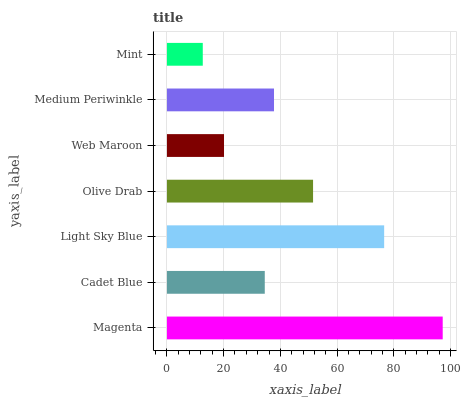Is Mint the minimum?
Answer yes or no. Yes. Is Magenta the maximum?
Answer yes or no. Yes. Is Cadet Blue the minimum?
Answer yes or no. No. Is Cadet Blue the maximum?
Answer yes or no. No. Is Magenta greater than Cadet Blue?
Answer yes or no. Yes. Is Cadet Blue less than Magenta?
Answer yes or no. Yes. Is Cadet Blue greater than Magenta?
Answer yes or no. No. Is Magenta less than Cadet Blue?
Answer yes or no. No. Is Medium Periwinkle the high median?
Answer yes or no. Yes. Is Medium Periwinkle the low median?
Answer yes or no. Yes. Is Mint the high median?
Answer yes or no. No. Is Magenta the low median?
Answer yes or no. No. 